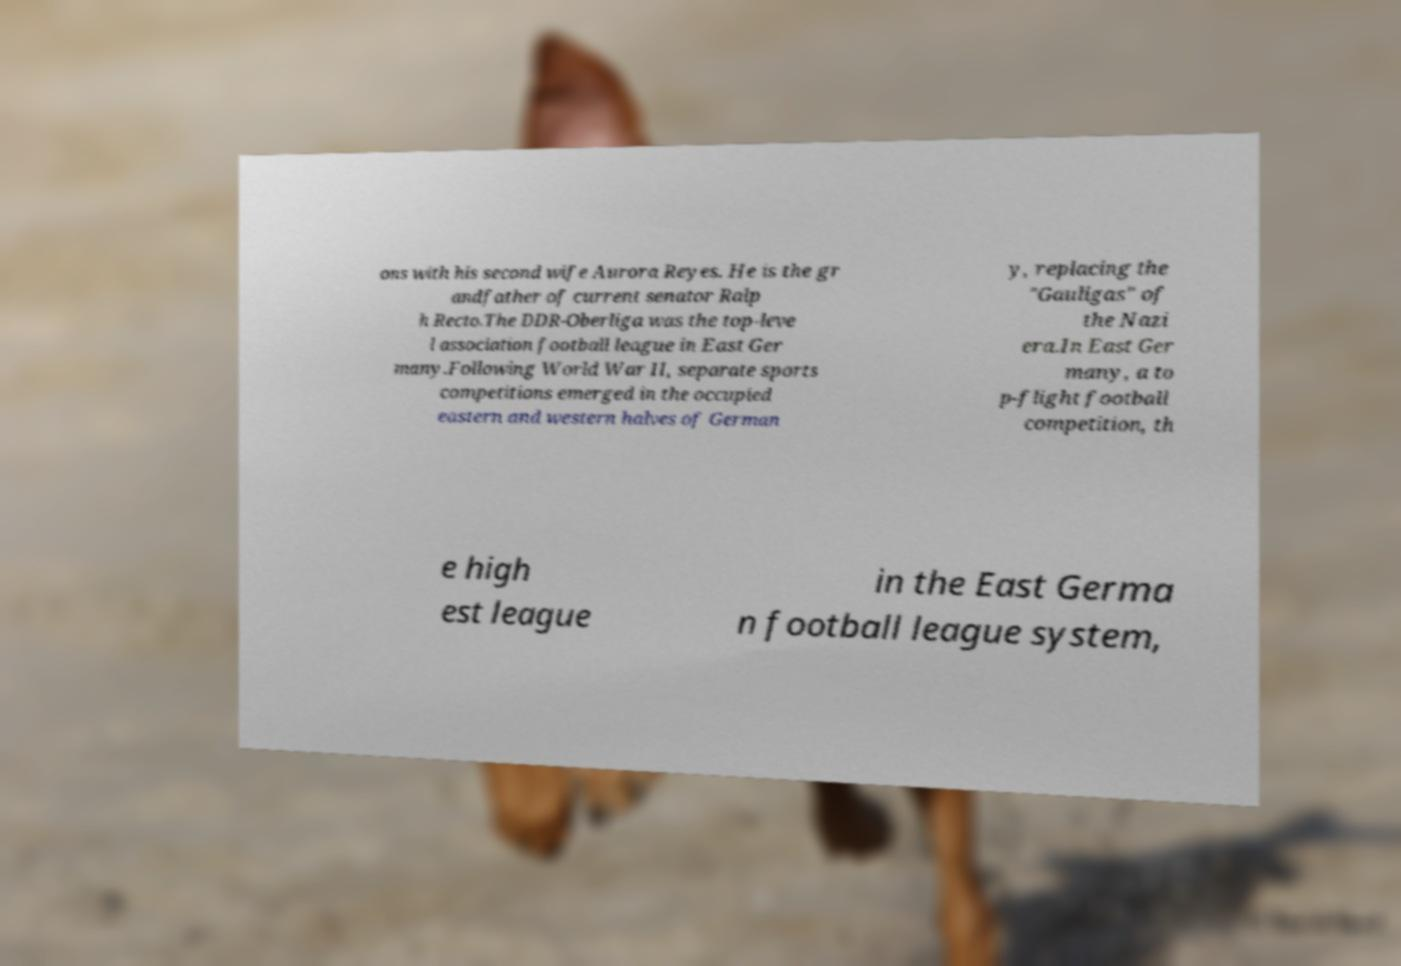There's text embedded in this image that I need extracted. Can you transcribe it verbatim? ons with his second wife Aurora Reyes. He is the gr andfather of current senator Ralp h Recto.The DDR-Oberliga was the top-leve l association football league in East Ger many.Following World War II, separate sports competitions emerged in the occupied eastern and western halves of German y, replacing the "Gauligas" of the Nazi era.In East Ger many, a to p-flight football competition, th e high est league in the East Germa n football league system, 